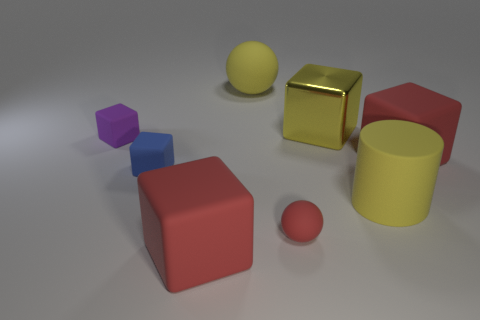What number of small red rubber things have the same shape as the tiny purple object?
Your answer should be compact. 0. Is there any other thing that has the same size as the cylinder?
Ensure brevity in your answer.  Yes. What size is the red rubber block on the left side of the yellow rubber thing that is right of the yellow matte sphere?
Offer a terse response. Large. There is a red sphere that is the same size as the blue cube; what material is it?
Your answer should be very brief. Rubber. Is there a large blue ball made of the same material as the large yellow ball?
Keep it short and to the point. No. There is a matte cube right of the yellow matte thing that is right of the yellow rubber object that is behind the yellow metallic cube; what color is it?
Your answer should be compact. Red. Does the small rubber cube behind the blue object have the same color as the ball left of the red rubber ball?
Offer a terse response. No. Are there any other things that are the same color as the metallic cube?
Your answer should be compact. Yes. Is the number of large yellow objects that are in front of the big yellow cylinder less than the number of tiny purple things?
Ensure brevity in your answer.  Yes. What number of spheres are there?
Provide a short and direct response. 2. 